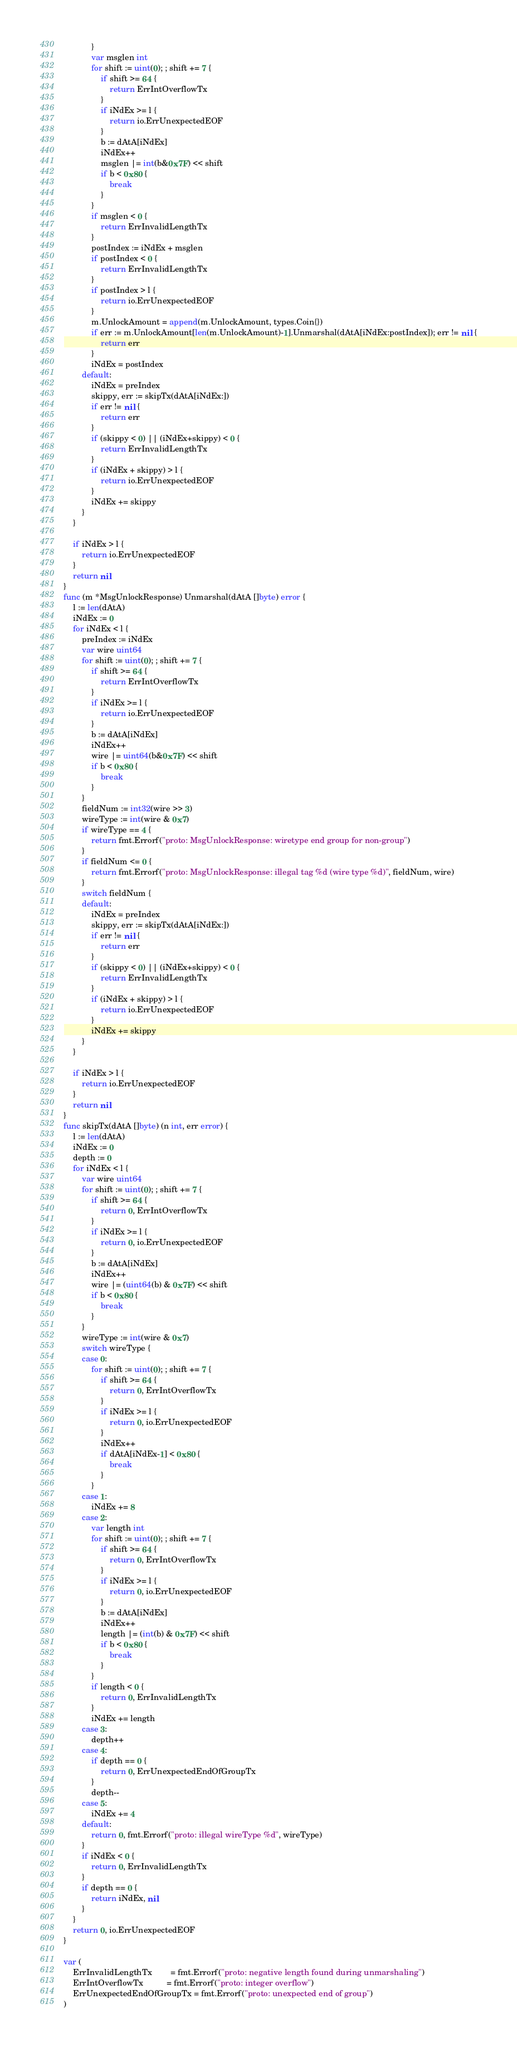<code> <loc_0><loc_0><loc_500><loc_500><_Go_>			}
			var msglen int
			for shift := uint(0); ; shift += 7 {
				if shift >= 64 {
					return ErrIntOverflowTx
				}
				if iNdEx >= l {
					return io.ErrUnexpectedEOF
				}
				b := dAtA[iNdEx]
				iNdEx++
				msglen |= int(b&0x7F) << shift
				if b < 0x80 {
					break
				}
			}
			if msglen < 0 {
				return ErrInvalidLengthTx
			}
			postIndex := iNdEx + msglen
			if postIndex < 0 {
				return ErrInvalidLengthTx
			}
			if postIndex > l {
				return io.ErrUnexpectedEOF
			}
			m.UnlockAmount = append(m.UnlockAmount, types.Coin{})
			if err := m.UnlockAmount[len(m.UnlockAmount)-1].Unmarshal(dAtA[iNdEx:postIndex]); err != nil {
				return err
			}
			iNdEx = postIndex
		default:
			iNdEx = preIndex
			skippy, err := skipTx(dAtA[iNdEx:])
			if err != nil {
				return err
			}
			if (skippy < 0) || (iNdEx+skippy) < 0 {
				return ErrInvalidLengthTx
			}
			if (iNdEx + skippy) > l {
				return io.ErrUnexpectedEOF
			}
			iNdEx += skippy
		}
	}

	if iNdEx > l {
		return io.ErrUnexpectedEOF
	}
	return nil
}
func (m *MsgUnlockResponse) Unmarshal(dAtA []byte) error {
	l := len(dAtA)
	iNdEx := 0
	for iNdEx < l {
		preIndex := iNdEx
		var wire uint64
		for shift := uint(0); ; shift += 7 {
			if shift >= 64 {
				return ErrIntOverflowTx
			}
			if iNdEx >= l {
				return io.ErrUnexpectedEOF
			}
			b := dAtA[iNdEx]
			iNdEx++
			wire |= uint64(b&0x7F) << shift
			if b < 0x80 {
				break
			}
		}
		fieldNum := int32(wire >> 3)
		wireType := int(wire & 0x7)
		if wireType == 4 {
			return fmt.Errorf("proto: MsgUnlockResponse: wiretype end group for non-group")
		}
		if fieldNum <= 0 {
			return fmt.Errorf("proto: MsgUnlockResponse: illegal tag %d (wire type %d)", fieldNum, wire)
		}
		switch fieldNum {
		default:
			iNdEx = preIndex
			skippy, err := skipTx(dAtA[iNdEx:])
			if err != nil {
				return err
			}
			if (skippy < 0) || (iNdEx+skippy) < 0 {
				return ErrInvalidLengthTx
			}
			if (iNdEx + skippy) > l {
				return io.ErrUnexpectedEOF
			}
			iNdEx += skippy
		}
	}

	if iNdEx > l {
		return io.ErrUnexpectedEOF
	}
	return nil
}
func skipTx(dAtA []byte) (n int, err error) {
	l := len(dAtA)
	iNdEx := 0
	depth := 0
	for iNdEx < l {
		var wire uint64
		for shift := uint(0); ; shift += 7 {
			if shift >= 64 {
				return 0, ErrIntOverflowTx
			}
			if iNdEx >= l {
				return 0, io.ErrUnexpectedEOF
			}
			b := dAtA[iNdEx]
			iNdEx++
			wire |= (uint64(b) & 0x7F) << shift
			if b < 0x80 {
				break
			}
		}
		wireType := int(wire & 0x7)
		switch wireType {
		case 0:
			for shift := uint(0); ; shift += 7 {
				if shift >= 64 {
					return 0, ErrIntOverflowTx
				}
				if iNdEx >= l {
					return 0, io.ErrUnexpectedEOF
				}
				iNdEx++
				if dAtA[iNdEx-1] < 0x80 {
					break
				}
			}
		case 1:
			iNdEx += 8
		case 2:
			var length int
			for shift := uint(0); ; shift += 7 {
				if shift >= 64 {
					return 0, ErrIntOverflowTx
				}
				if iNdEx >= l {
					return 0, io.ErrUnexpectedEOF
				}
				b := dAtA[iNdEx]
				iNdEx++
				length |= (int(b) & 0x7F) << shift
				if b < 0x80 {
					break
				}
			}
			if length < 0 {
				return 0, ErrInvalidLengthTx
			}
			iNdEx += length
		case 3:
			depth++
		case 4:
			if depth == 0 {
				return 0, ErrUnexpectedEndOfGroupTx
			}
			depth--
		case 5:
			iNdEx += 4
		default:
			return 0, fmt.Errorf("proto: illegal wireType %d", wireType)
		}
		if iNdEx < 0 {
			return 0, ErrInvalidLengthTx
		}
		if depth == 0 {
			return iNdEx, nil
		}
	}
	return 0, io.ErrUnexpectedEOF
}

var (
	ErrInvalidLengthTx        = fmt.Errorf("proto: negative length found during unmarshaling")
	ErrIntOverflowTx          = fmt.Errorf("proto: integer overflow")
	ErrUnexpectedEndOfGroupTx = fmt.Errorf("proto: unexpected end of group")
)
</code> 